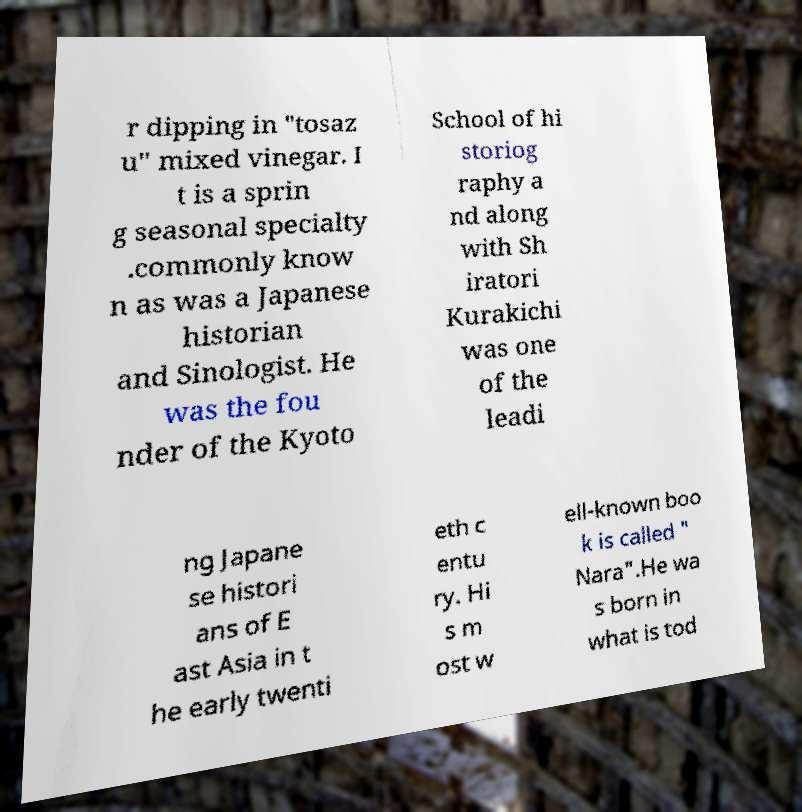There's text embedded in this image that I need extracted. Can you transcribe it verbatim? r dipping in "tosaz u" mixed vinegar. I t is a sprin g seasonal specialty .commonly know n as was a Japanese historian and Sinologist. He was the fou nder of the Kyoto School of hi storiog raphy a nd along with Sh iratori Kurakichi was one of the leadi ng Japane se histori ans of E ast Asia in t he early twenti eth c entu ry. Hi s m ost w ell-known boo k is called " Nara".He wa s born in what is tod 